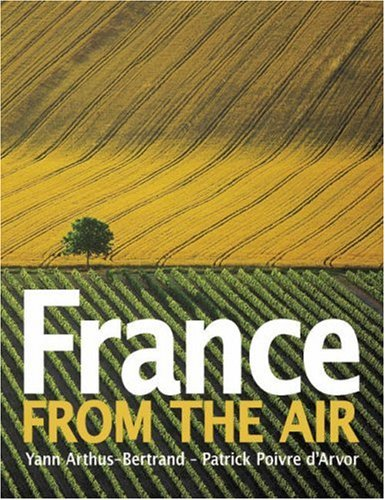What is the title of this book? The title of this visually stunning book is 'France from the Air,' which explores the rich landscapes of France from a unique aerial perspective. 